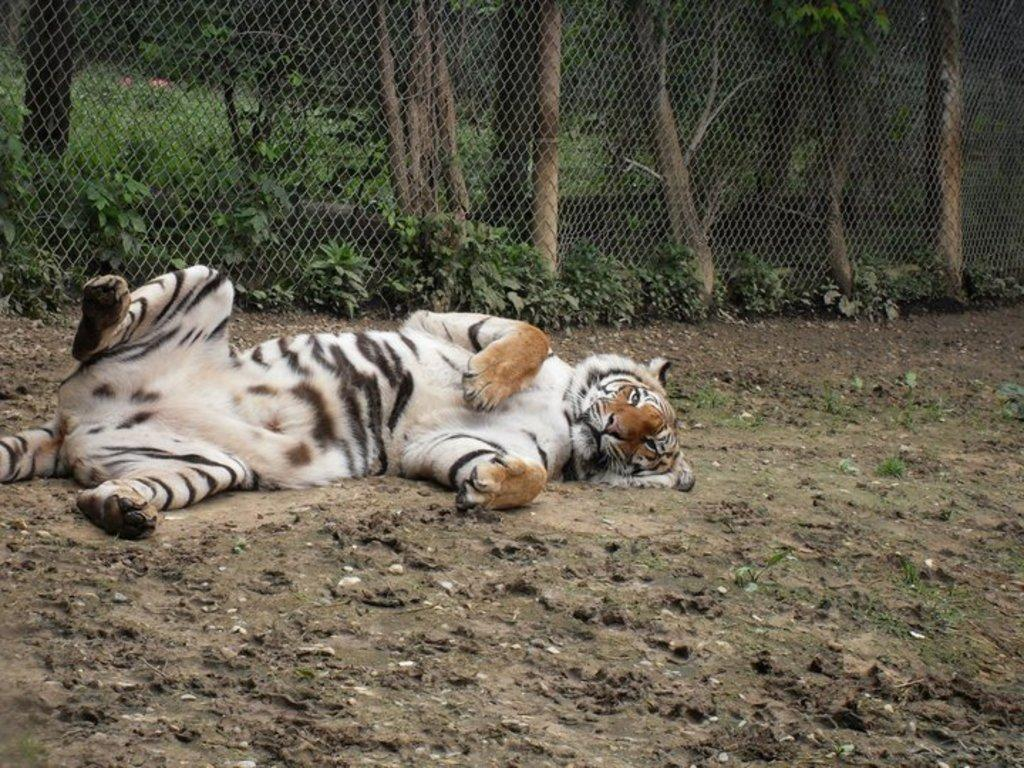What animal is lying on the ground in the image? There is a tiger lying on the ground in the image. What type of vegetation can be seen in the image? There are plants visible in the image. What is the purpose of the structure in the image? There is a fence in the image, which may serve as a barrier or boundary. What can be seen behind the fence in the image? Trees are visible behind the fence in the image. What type of brain is visible in the image? There is no brain visible in the image; it features a tiger lying on the ground, plants, a fence, and trees. What type of pump is being used by the minister in the image? There is no minister or pump present in the image. 